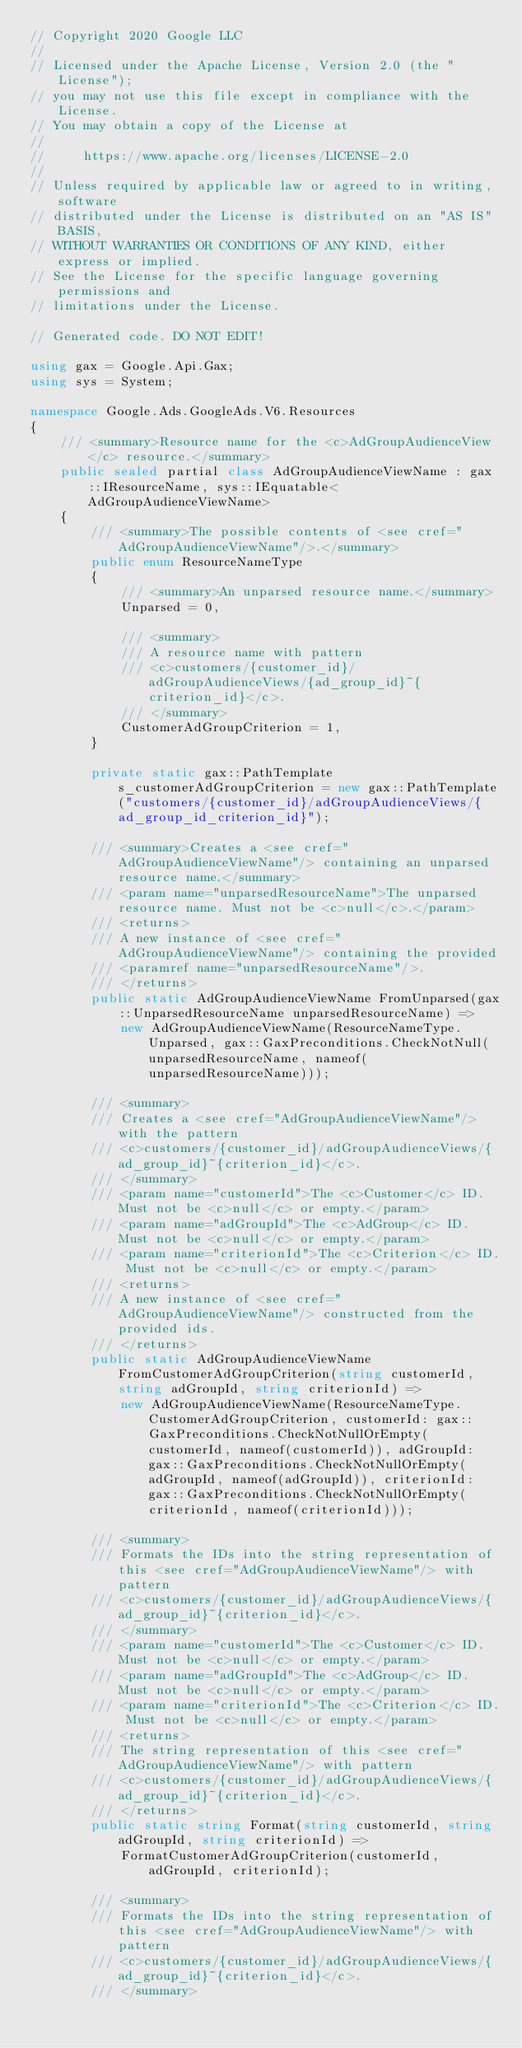<code> <loc_0><loc_0><loc_500><loc_500><_C#_>// Copyright 2020 Google LLC
//
// Licensed under the Apache License, Version 2.0 (the "License");
// you may not use this file except in compliance with the License.
// You may obtain a copy of the License at
//
//     https://www.apache.org/licenses/LICENSE-2.0
//
// Unless required by applicable law or agreed to in writing, software
// distributed under the License is distributed on an "AS IS" BASIS,
// WITHOUT WARRANTIES OR CONDITIONS OF ANY KIND, either express or implied.
// See the License for the specific language governing permissions and
// limitations under the License.

// Generated code. DO NOT EDIT!

using gax = Google.Api.Gax;
using sys = System;

namespace Google.Ads.GoogleAds.V6.Resources
{
    /// <summary>Resource name for the <c>AdGroupAudienceView</c> resource.</summary>
    public sealed partial class AdGroupAudienceViewName : gax::IResourceName, sys::IEquatable<AdGroupAudienceViewName>
    {
        /// <summary>The possible contents of <see cref="AdGroupAudienceViewName"/>.</summary>
        public enum ResourceNameType
        {
            /// <summary>An unparsed resource name.</summary>
            Unparsed = 0,

            /// <summary>
            /// A resource name with pattern
            /// <c>customers/{customer_id}/adGroupAudienceViews/{ad_group_id}~{criterion_id}</c>.
            /// </summary>
            CustomerAdGroupCriterion = 1,
        }

        private static gax::PathTemplate s_customerAdGroupCriterion = new gax::PathTemplate("customers/{customer_id}/adGroupAudienceViews/{ad_group_id_criterion_id}");

        /// <summary>Creates a <see cref="AdGroupAudienceViewName"/> containing an unparsed resource name.</summary>
        /// <param name="unparsedResourceName">The unparsed resource name. Must not be <c>null</c>.</param>
        /// <returns>
        /// A new instance of <see cref="AdGroupAudienceViewName"/> containing the provided
        /// <paramref name="unparsedResourceName"/>.
        /// </returns>
        public static AdGroupAudienceViewName FromUnparsed(gax::UnparsedResourceName unparsedResourceName) =>
            new AdGroupAudienceViewName(ResourceNameType.Unparsed, gax::GaxPreconditions.CheckNotNull(unparsedResourceName, nameof(unparsedResourceName)));

        /// <summary>
        /// Creates a <see cref="AdGroupAudienceViewName"/> with the pattern
        /// <c>customers/{customer_id}/adGroupAudienceViews/{ad_group_id}~{criterion_id}</c>.
        /// </summary>
        /// <param name="customerId">The <c>Customer</c> ID. Must not be <c>null</c> or empty.</param>
        /// <param name="adGroupId">The <c>AdGroup</c> ID. Must not be <c>null</c> or empty.</param>
        /// <param name="criterionId">The <c>Criterion</c> ID. Must not be <c>null</c> or empty.</param>
        /// <returns>
        /// A new instance of <see cref="AdGroupAudienceViewName"/> constructed from the provided ids.
        /// </returns>
        public static AdGroupAudienceViewName FromCustomerAdGroupCriterion(string customerId, string adGroupId, string criterionId) =>
            new AdGroupAudienceViewName(ResourceNameType.CustomerAdGroupCriterion, customerId: gax::GaxPreconditions.CheckNotNullOrEmpty(customerId, nameof(customerId)), adGroupId: gax::GaxPreconditions.CheckNotNullOrEmpty(adGroupId, nameof(adGroupId)), criterionId: gax::GaxPreconditions.CheckNotNullOrEmpty(criterionId, nameof(criterionId)));

        /// <summary>
        /// Formats the IDs into the string representation of this <see cref="AdGroupAudienceViewName"/> with pattern
        /// <c>customers/{customer_id}/adGroupAudienceViews/{ad_group_id}~{criterion_id}</c>.
        /// </summary>
        /// <param name="customerId">The <c>Customer</c> ID. Must not be <c>null</c> or empty.</param>
        /// <param name="adGroupId">The <c>AdGroup</c> ID. Must not be <c>null</c> or empty.</param>
        /// <param name="criterionId">The <c>Criterion</c> ID. Must not be <c>null</c> or empty.</param>
        /// <returns>
        /// The string representation of this <see cref="AdGroupAudienceViewName"/> with pattern
        /// <c>customers/{customer_id}/adGroupAudienceViews/{ad_group_id}~{criterion_id}</c>.
        /// </returns>
        public static string Format(string customerId, string adGroupId, string criterionId) =>
            FormatCustomerAdGroupCriterion(customerId, adGroupId, criterionId);

        /// <summary>
        /// Formats the IDs into the string representation of this <see cref="AdGroupAudienceViewName"/> with pattern
        /// <c>customers/{customer_id}/adGroupAudienceViews/{ad_group_id}~{criterion_id}</c>.
        /// </summary></code> 